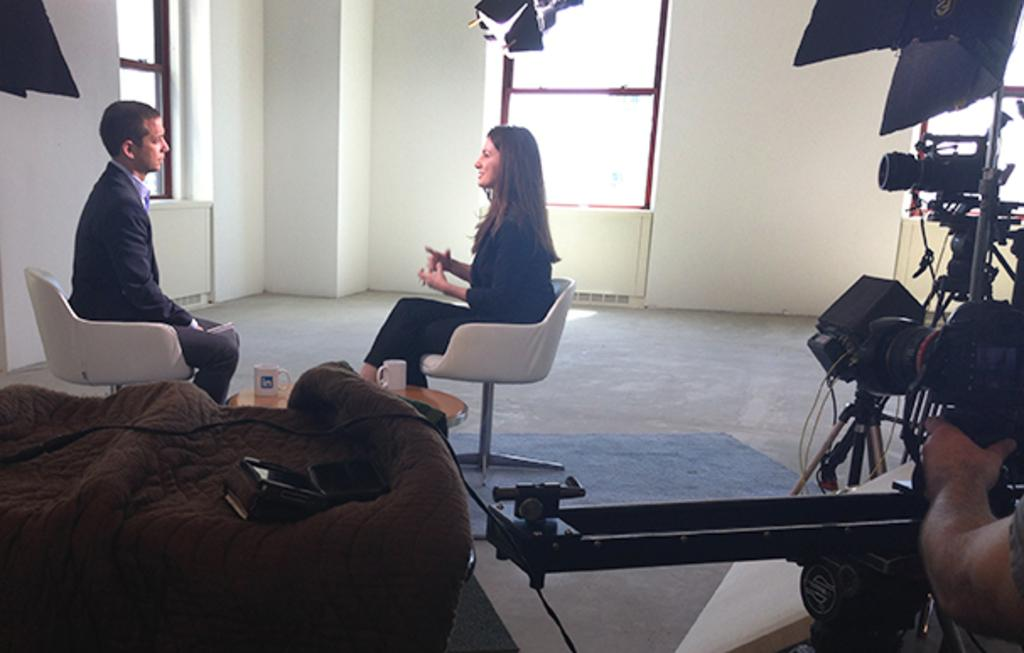How many people are in the image? There are two people in the image. What are the people doing in the image? The people are sitting on chairs. Can you describe any objects in the room? There is a camera in the room. What type of blade is being used by one of the people in the image? There is no blade present in the image; the people are sitting on chairs and there is a camera in the room. 